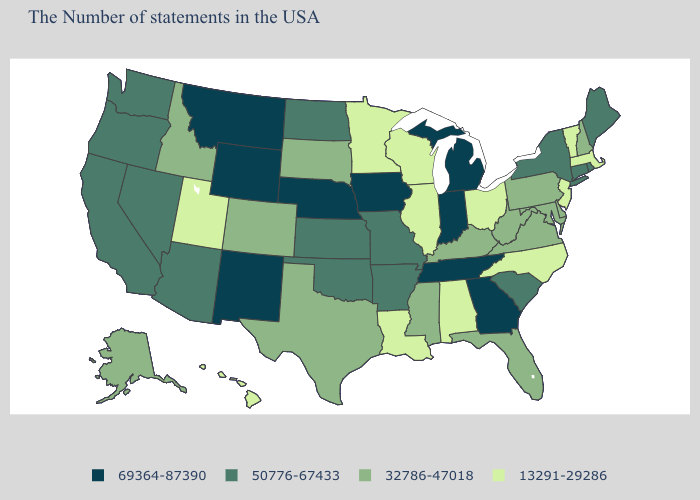Name the states that have a value in the range 69364-87390?
Quick response, please. Georgia, Michigan, Indiana, Tennessee, Iowa, Nebraska, Wyoming, New Mexico, Montana. What is the lowest value in states that border Ohio?
Be succinct. 32786-47018. What is the highest value in the USA?
Answer briefly. 69364-87390. What is the value of Michigan?
Give a very brief answer. 69364-87390. What is the value of Kansas?
Answer briefly. 50776-67433. What is the lowest value in the USA?
Quick response, please. 13291-29286. Does Wyoming have the highest value in the USA?
Short answer required. Yes. What is the value of Indiana?
Quick response, please. 69364-87390. Does the first symbol in the legend represent the smallest category?
Write a very short answer. No. Does Rhode Island have the same value as Hawaii?
Quick response, please. No. What is the value of Massachusetts?
Answer briefly. 13291-29286. Which states hav the highest value in the South?
Write a very short answer. Georgia, Tennessee. Among the states that border Iowa , does Nebraska have the highest value?
Short answer required. Yes. Does Minnesota have the lowest value in the MidWest?
Be succinct. Yes. Name the states that have a value in the range 13291-29286?
Give a very brief answer. Massachusetts, Vermont, New Jersey, North Carolina, Ohio, Alabama, Wisconsin, Illinois, Louisiana, Minnesota, Utah, Hawaii. 